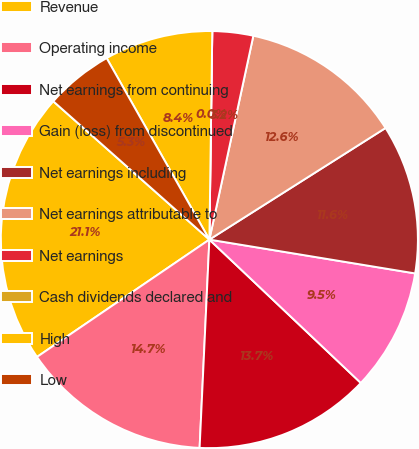Convert chart. <chart><loc_0><loc_0><loc_500><loc_500><pie_chart><fcel>Revenue<fcel>Operating income<fcel>Net earnings from continuing<fcel>Gain (loss) from discontinued<fcel>Net earnings including<fcel>Net earnings attributable to<fcel>Net earnings<fcel>Cash dividends declared and<fcel>High<fcel>Low<nl><fcel>21.05%<fcel>14.74%<fcel>13.68%<fcel>9.47%<fcel>11.58%<fcel>12.63%<fcel>3.16%<fcel>0.0%<fcel>8.42%<fcel>5.26%<nl></chart> 